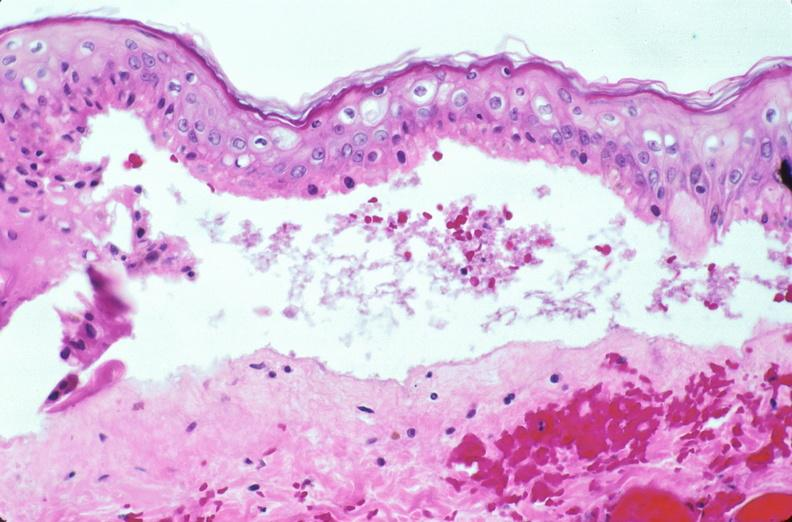does linear fracture in occiput show skin, epidermolysis bullosa?
Answer the question using a single word or phrase. No 